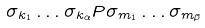<formula> <loc_0><loc_0><loc_500><loc_500>\sigma _ { k _ { 1 } } \dots \sigma _ { k _ { \alpha } } P \sigma _ { m _ { 1 } } \dots \sigma _ { m _ { \beta } }</formula> 